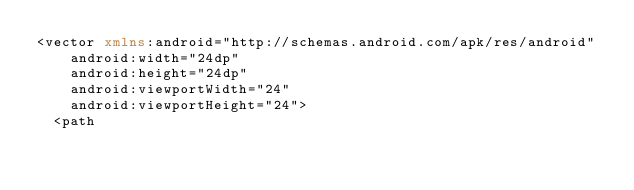<code> <loc_0><loc_0><loc_500><loc_500><_XML_><vector xmlns:android="http://schemas.android.com/apk/res/android"
    android:width="24dp"
    android:height="24dp"
    android:viewportWidth="24"
    android:viewportHeight="24">
  <path</code> 